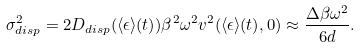<formula> <loc_0><loc_0><loc_500><loc_500>\sigma ^ { 2 } _ { d i s p } = 2 D _ { d i s p } ( \langle \epsilon \rangle ( t ) ) \beta ^ { 2 } \omega ^ { 2 } v ^ { 2 } ( \langle \epsilon \rangle ( t ) , 0 ) \approx \frac { \Delta \beta \omega ^ { 2 } } { 6 d } .</formula> 